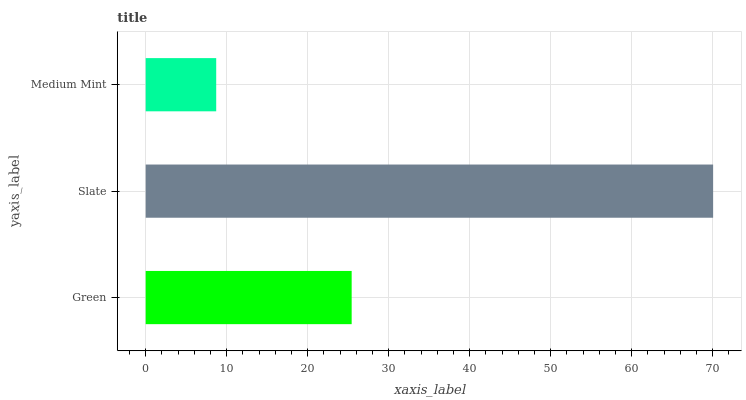Is Medium Mint the minimum?
Answer yes or no. Yes. Is Slate the maximum?
Answer yes or no. Yes. Is Slate the minimum?
Answer yes or no. No. Is Medium Mint the maximum?
Answer yes or no. No. Is Slate greater than Medium Mint?
Answer yes or no. Yes. Is Medium Mint less than Slate?
Answer yes or no. Yes. Is Medium Mint greater than Slate?
Answer yes or no. No. Is Slate less than Medium Mint?
Answer yes or no. No. Is Green the high median?
Answer yes or no. Yes. Is Green the low median?
Answer yes or no. Yes. Is Slate the high median?
Answer yes or no. No. Is Slate the low median?
Answer yes or no. No. 